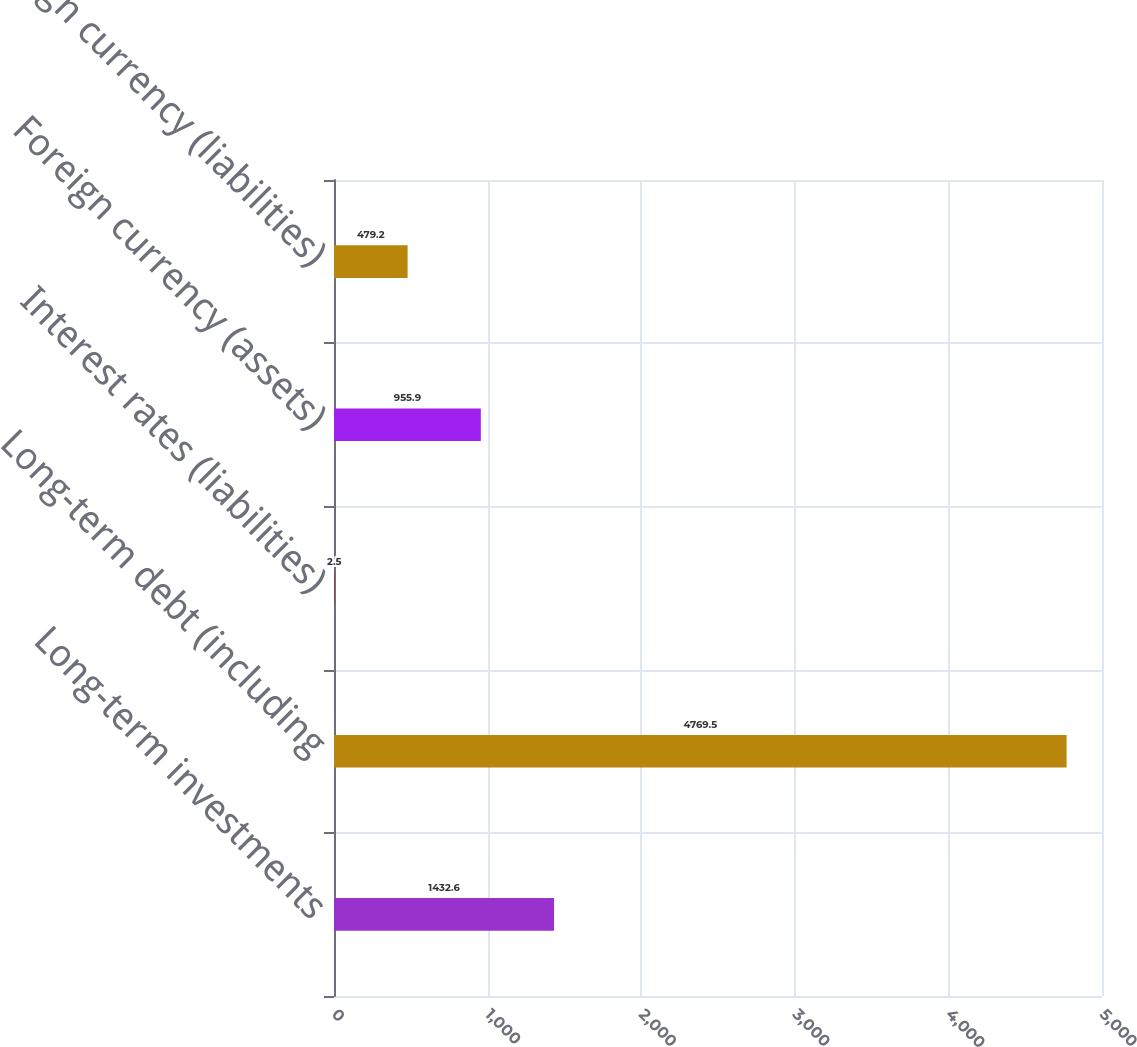<chart> <loc_0><loc_0><loc_500><loc_500><bar_chart><fcel>Long-term investments<fcel>Long-term debt (including<fcel>Interest rates (liabilities)<fcel>Foreign currency (assets)<fcel>Foreign currency (liabilities)<nl><fcel>1432.6<fcel>4769.5<fcel>2.5<fcel>955.9<fcel>479.2<nl></chart> 